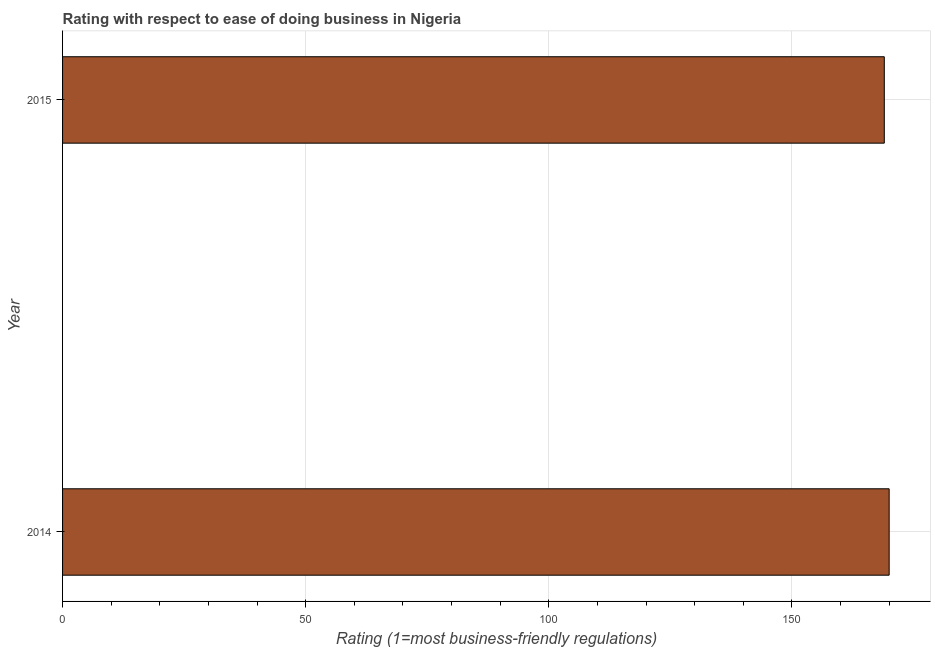What is the title of the graph?
Keep it short and to the point. Rating with respect to ease of doing business in Nigeria. What is the label or title of the X-axis?
Your answer should be very brief. Rating (1=most business-friendly regulations). What is the ease of doing business index in 2014?
Offer a very short reply. 170. Across all years, what is the maximum ease of doing business index?
Provide a succinct answer. 170. Across all years, what is the minimum ease of doing business index?
Give a very brief answer. 169. In which year was the ease of doing business index maximum?
Ensure brevity in your answer.  2014. In which year was the ease of doing business index minimum?
Make the answer very short. 2015. What is the sum of the ease of doing business index?
Ensure brevity in your answer.  339. What is the average ease of doing business index per year?
Offer a terse response. 169. What is the median ease of doing business index?
Keep it short and to the point. 169.5. Is the ease of doing business index in 2014 less than that in 2015?
Your answer should be very brief. No. In how many years, is the ease of doing business index greater than the average ease of doing business index taken over all years?
Make the answer very short. 1. Are all the bars in the graph horizontal?
Make the answer very short. Yes. How many years are there in the graph?
Provide a succinct answer. 2. What is the Rating (1=most business-friendly regulations) in 2014?
Provide a succinct answer. 170. What is the Rating (1=most business-friendly regulations) in 2015?
Your answer should be very brief. 169. 